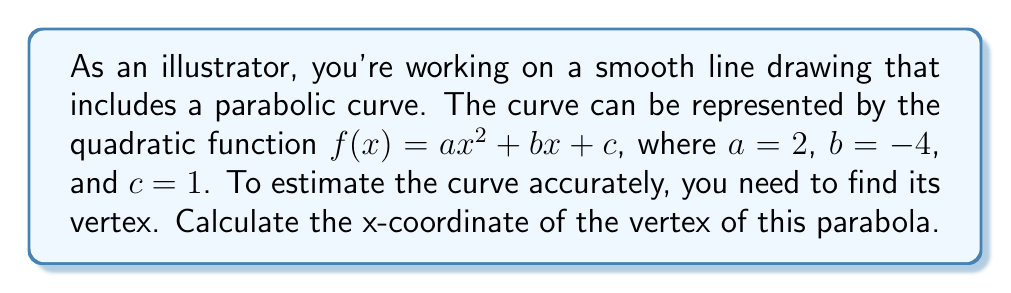Help me with this question. To find the x-coordinate of the vertex of a parabola, we can use the formula:

$x = -\frac{b}{2a}$

Where $a$ and $b$ are the coefficients of the quadratic function $f(x) = ax^2 + bx + c$.

Given:
$a = 2$
$b = -4$
$c = 1$ (not needed for this calculation)

Step 1: Substitute the values into the formula:
$x = -\frac{(-4)}{2(2)}$

Step 2: Simplify the numerator:
$x = \frac{4}{2(2)}$

Step 3: Simplify the denominator:
$x = \frac{4}{4}$

Step 4: Perform the division:
$x = 1$

Therefore, the x-coordinate of the vertex is 1.
Answer: $1$ 